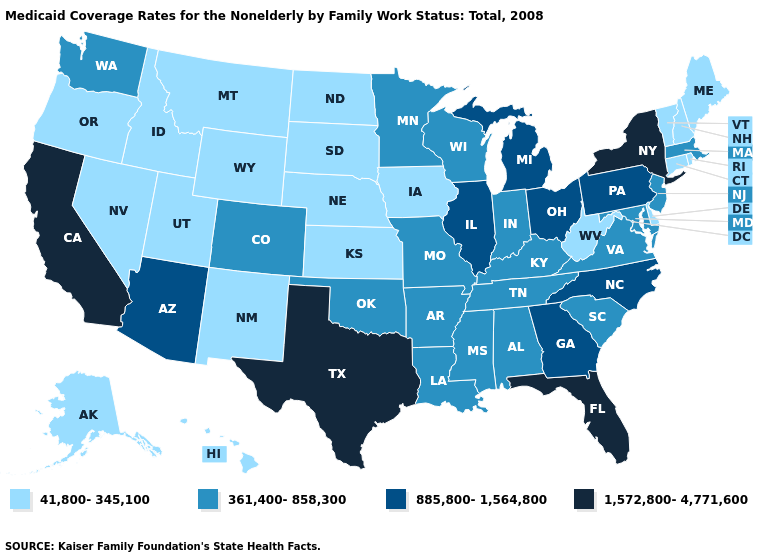What is the value of Vermont?
Give a very brief answer. 41,800-345,100. Does Texas have the highest value in the USA?
Quick response, please. Yes. Does Florida have the highest value in the USA?
Write a very short answer. Yes. Name the states that have a value in the range 1,572,800-4,771,600?
Concise answer only. California, Florida, New York, Texas. Name the states that have a value in the range 885,800-1,564,800?
Keep it brief. Arizona, Georgia, Illinois, Michigan, North Carolina, Ohio, Pennsylvania. What is the lowest value in the Northeast?
Short answer required. 41,800-345,100. Is the legend a continuous bar?
Concise answer only. No. What is the value of Pennsylvania?
Quick response, please. 885,800-1,564,800. Is the legend a continuous bar?
Short answer required. No. Name the states that have a value in the range 885,800-1,564,800?
Be succinct. Arizona, Georgia, Illinois, Michigan, North Carolina, Ohio, Pennsylvania. What is the value of Florida?
Keep it brief. 1,572,800-4,771,600. How many symbols are there in the legend?
Give a very brief answer. 4. Does South Carolina have a higher value than Minnesota?
Keep it brief. No. Name the states that have a value in the range 885,800-1,564,800?
Keep it brief. Arizona, Georgia, Illinois, Michigan, North Carolina, Ohio, Pennsylvania. Among the states that border North Dakota , which have the lowest value?
Concise answer only. Montana, South Dakota. 